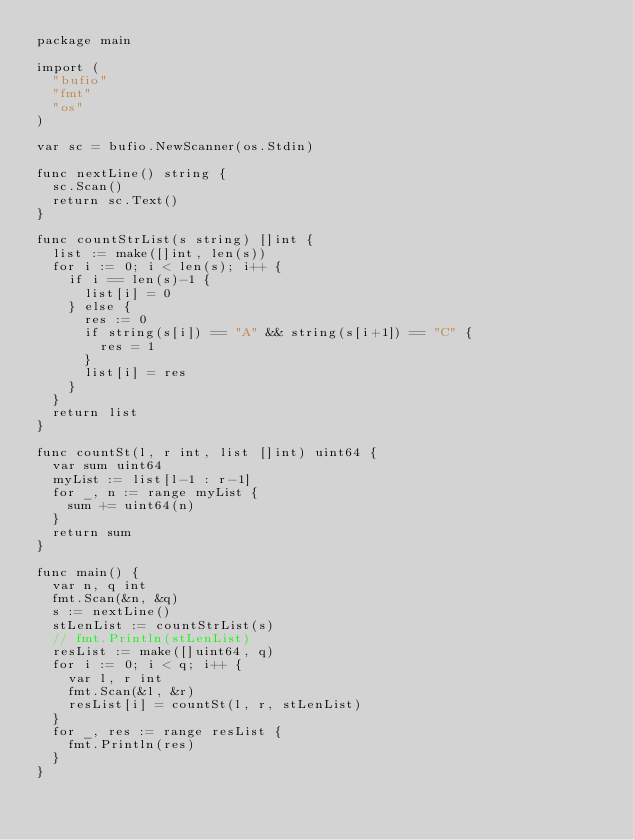<code> <loc_0><loc_0><loc_500><loc_500><_Go_>package main

import (
	"bufio"
	"fmt"
	"os"
)

var sc = bufio.NewScanner(os.Stdin)

func nextLine() string {
	sc.Scan()
	return sc.Text()
}

func countStrList(s string) []int {
	list := make([]int, len(s))
	for i := 0; i < len(s); i++ {
		if i == len(s)-1 {
			list[i] = 0
		} else {
			res := 0
			if string(s[i]) == "A" && string(s[i+1]) == "C" {
				res = 1
			}
			list[i] = res
		}
	}
	return list
}

func countSt(l, r int, list []int) uint64 {
	var sum uint64
	myList := list[l-1 : r-1]
	for _, n := range myList {
		sum += uint64(n)
	}
	return sum
}

func main() {
	var n, q int
	fmt.Scan(&n, &q)
	s := nextLine()
	stLenList := countStrList(s)
	// fmt.Println(stLenList)
	resList := make([]uint64, q)
	for i := 0; i < q; i++ {
		var l, r int
		fmt.Scan(&l, &r)
		resList[i] = countSt(l, r, stLenList)
	}
	for _, res := range resList {
		fmt.Println(res)
	}
}
</code> 